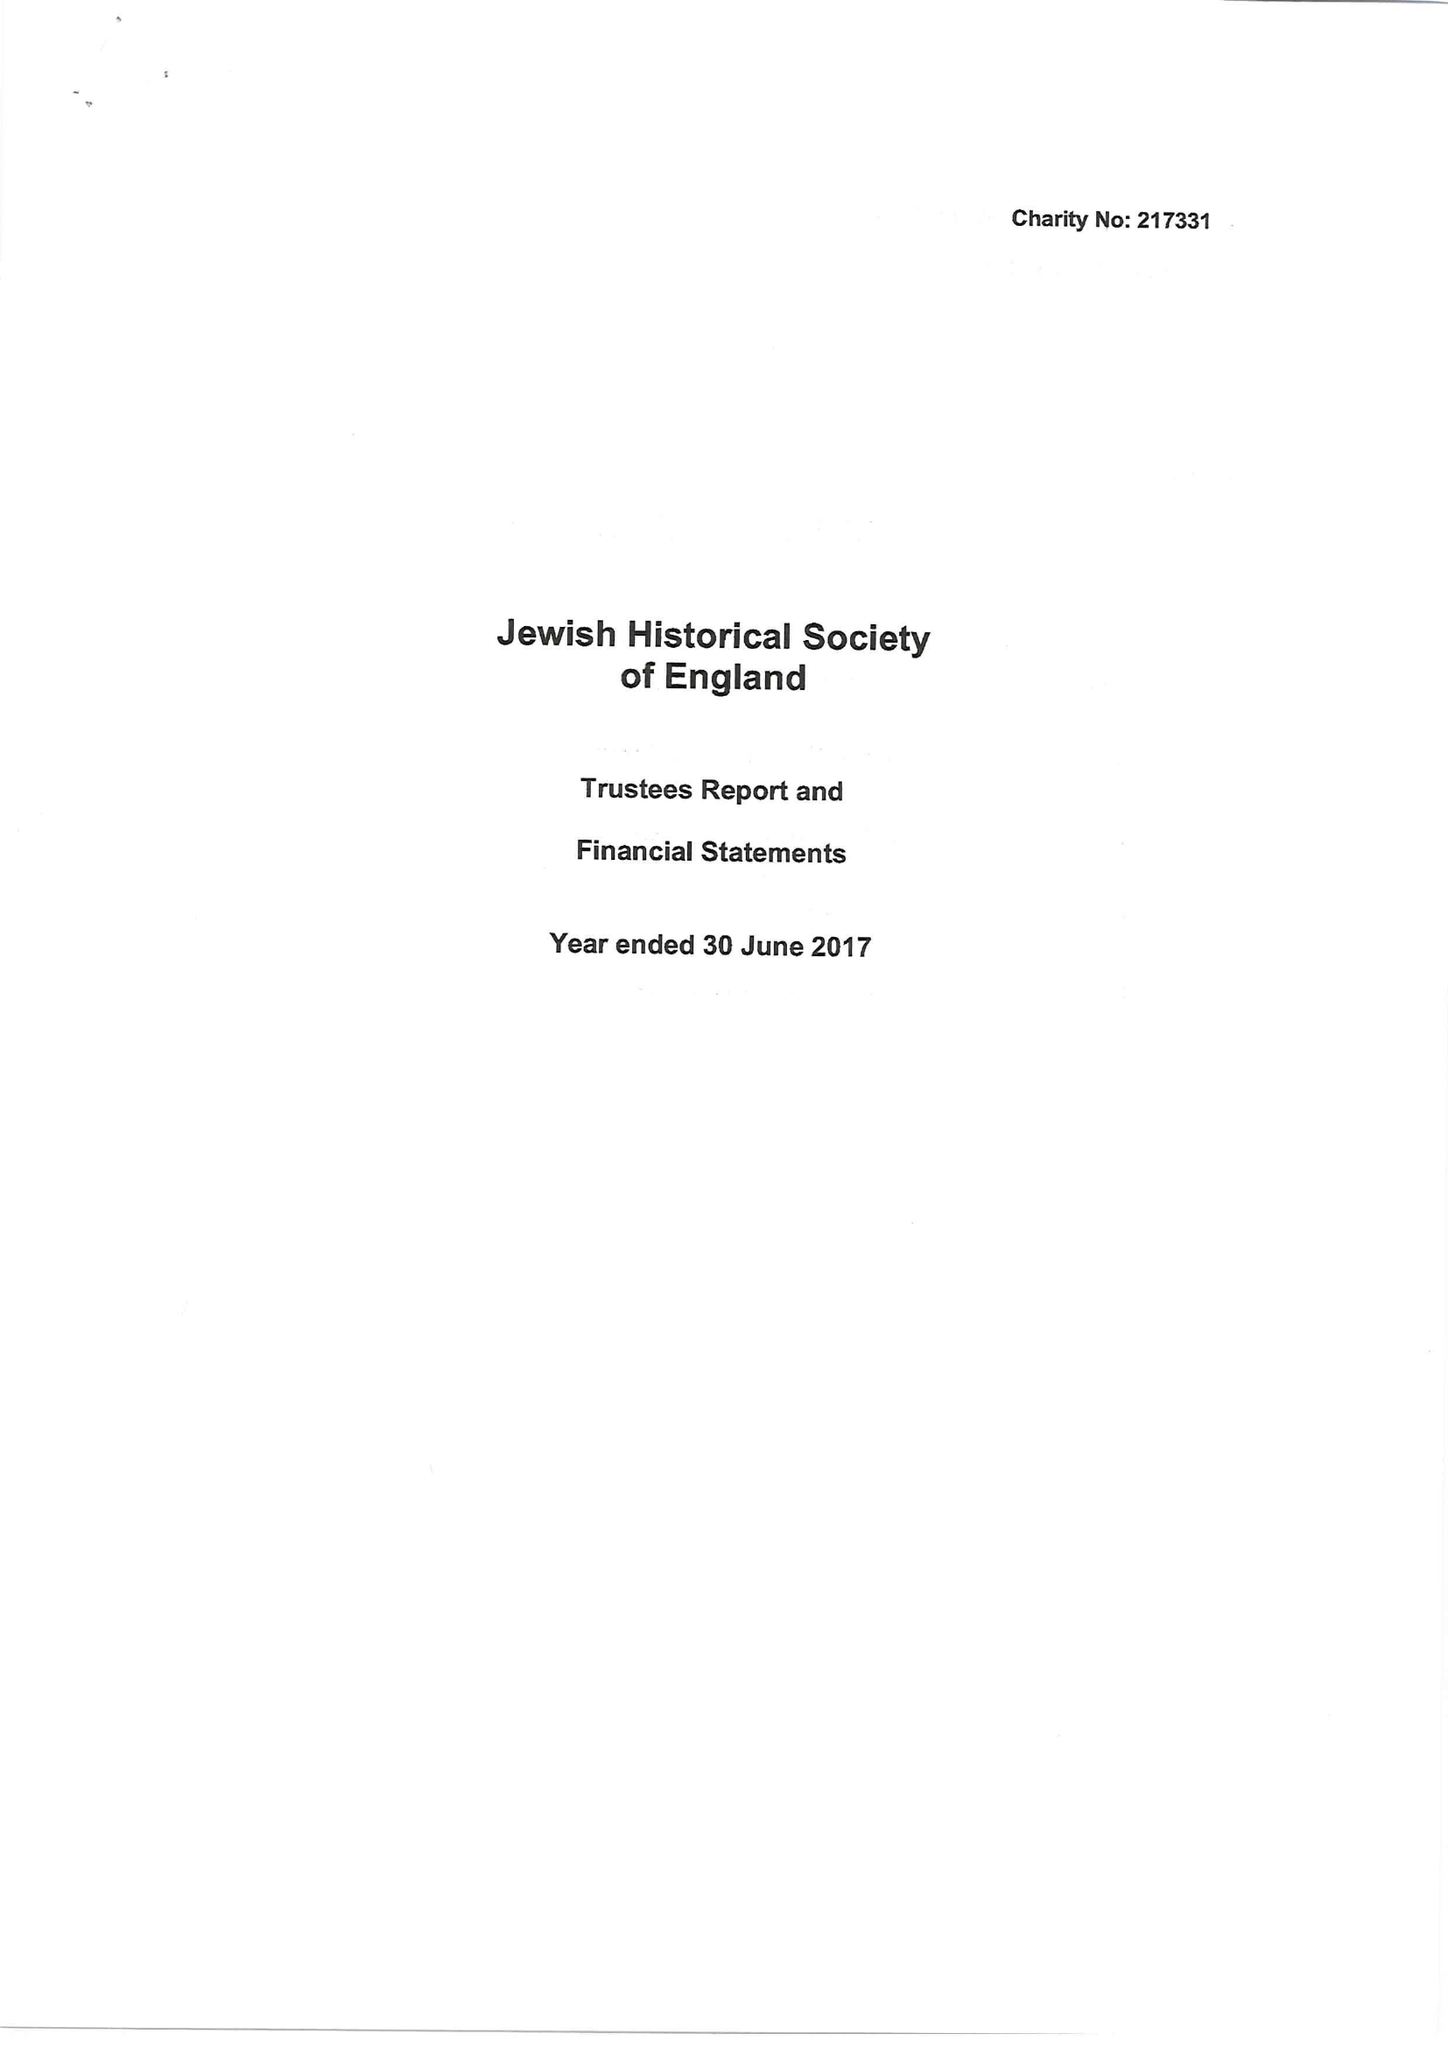What is the value for the address__street_line?
Answer the question using a single word or phrase. EAST WINCH ROAD 